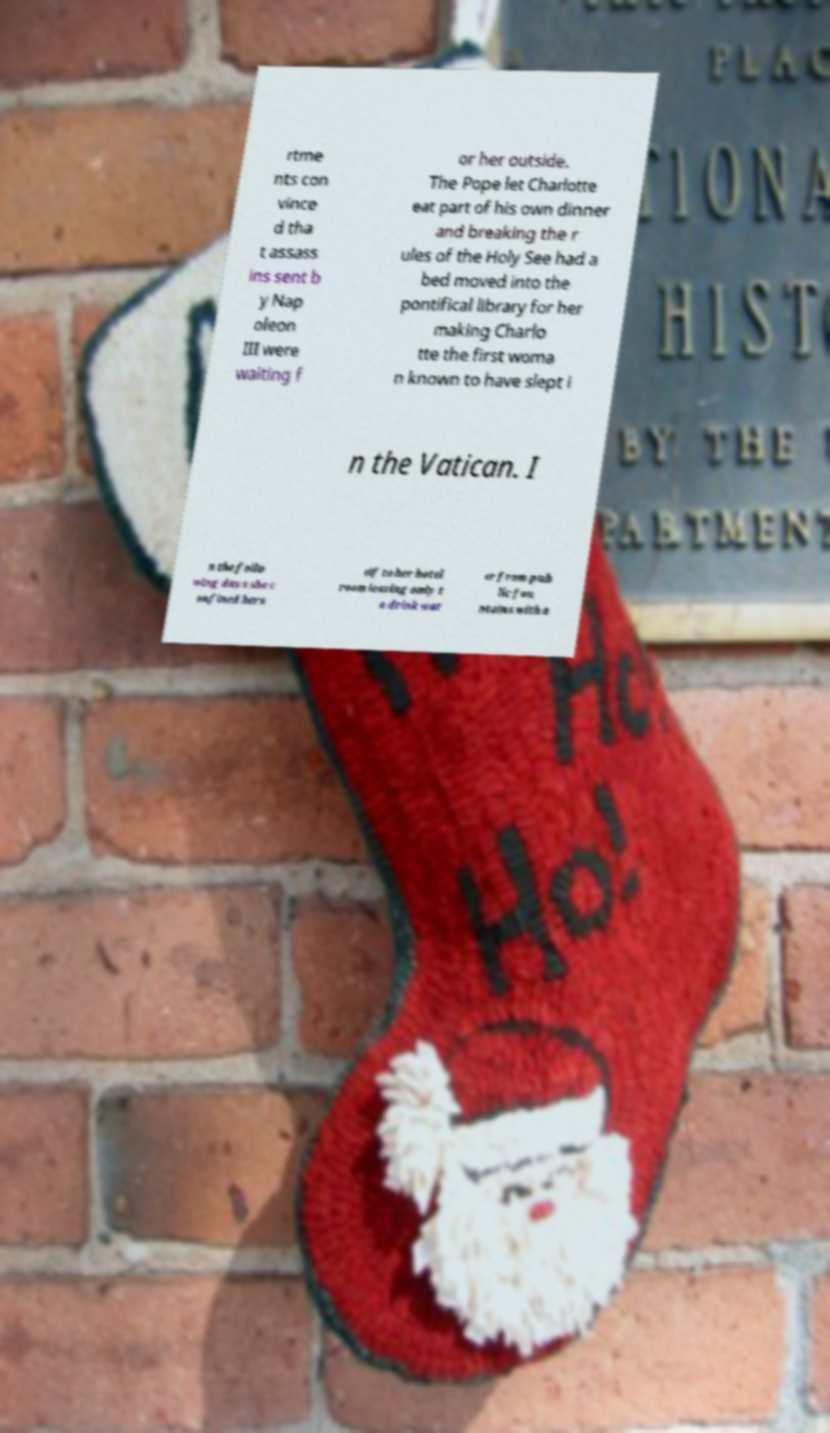Can you read and provide the text displayed in the image?This photo seems to have some interesting text. Can you extract and type it out for me? rtme nts con vince d tha t assass ins sent b y Nap oleon III were waiting f or her outside. The Pope let Charlotte eat part of his own dinner and breaking the r ules of the Holy See had a bed moved into the pontifical library for her making Charlo tte the first woma n known to have slept i n the Vatican. I n the follo wing days she c onfined hers elf to her hotel room leaving only t o drink wat er from pub lic fou ntains with a 